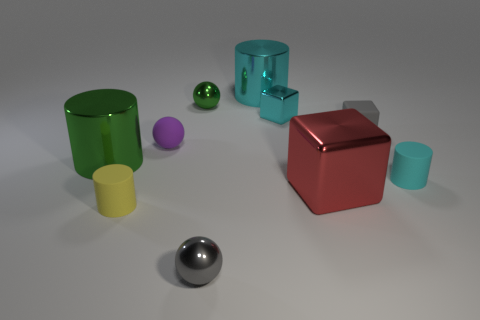What number of balls are metal objects or small green objects?
Keep it short and to the point. 2. What number of tiny spheres are both behind the gray shiny sphere and in front of the red metallic block?
Provide a succinct answer. 0. Is the size of the red block the same as the metal cylinder behind the green metallic cylinder?
Provide a short and direct response. Yes. Are there any small metal things that are on the right side of the large red block on the right side of the small cylinder on the left side of the tiny metal block?
Provide a succinct answer. No. There is a big cylinder on the left side of the tiny gray shiny object that is in front of the small metallic block; what is it made of?
Make the answer very short. Metal. There is a thing that is both behind the tiny cyan matte object and on the right side of the red object; what is its material?
Provide a succinct answer. Rubber. Is there a green thing of the same shape as the small cyan shiny object?
Your answer should be compact. No. There is a sphere that is behind the tiny gray matte block; are there any small green metal objects in front of it?
Keep it short and to the point. No. What number of big cyan objects have the same material as the small green sphere?
Keep it short and to the point. 1. Is there a small cyan shiny block?
Your response must be concise. Yes. 